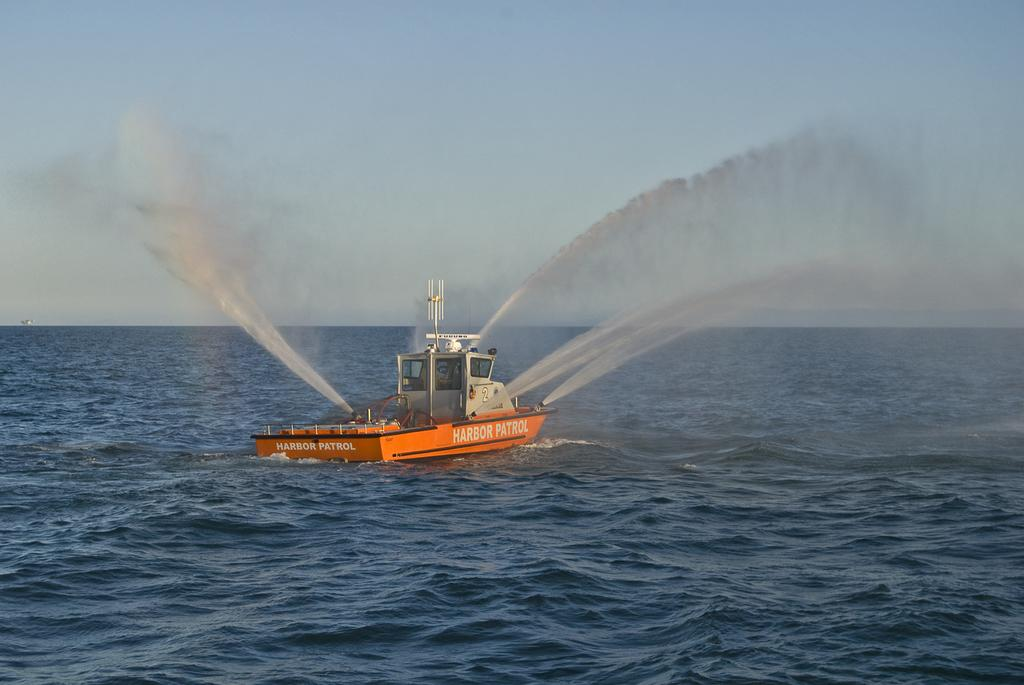What is the main subject in the center of the image? There is a boat in the center of the image. What can be seen in the background of the image? There is an ocean in the background of the image. Where is the zinc mine located in the image? There is no zinc mine present in the image. What type of volcano can be seen erupting in the background of the image? There is no volcano present in the image; it features a boat and an ocean. 